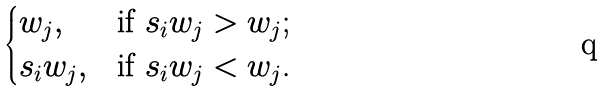<formula> <loc_0><loc_0><loc_500><loc_500>\begin{cases} w _ { j } , & \text {if $s_{i}w_{j}>w_{j}$;} \\ s _ { i } w _ { j } , & \text {if $s_{i}w_{j}<w_{j}$.} \end{cases}</formula> 